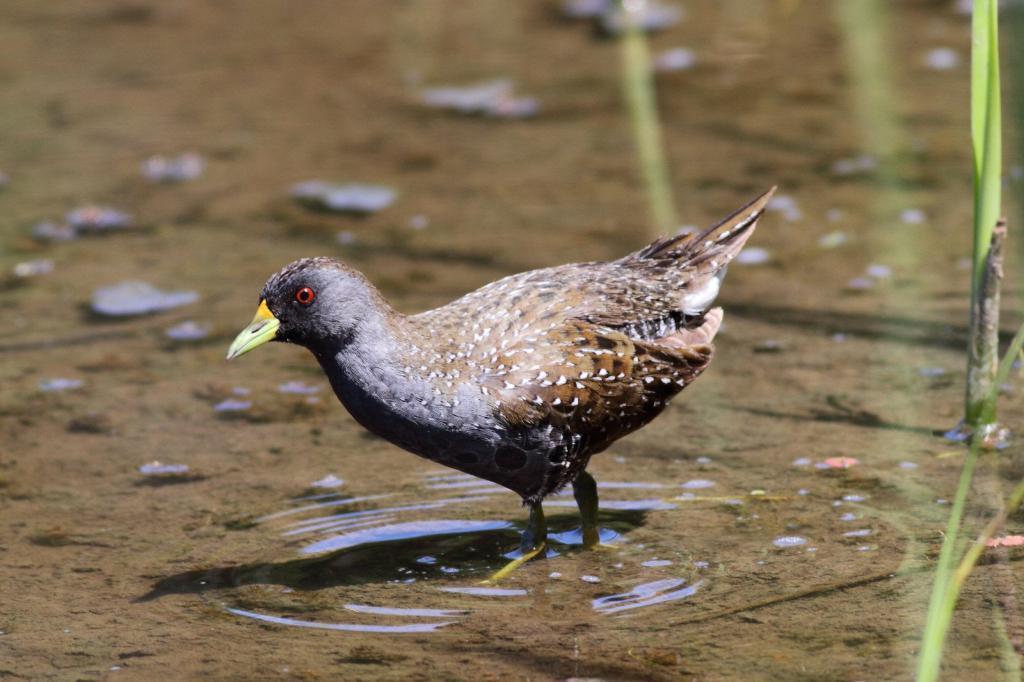Describe this image in one or two sentences. In this image I can see a bird. On the right side, I can see the plants. In the background, I can see the water. 